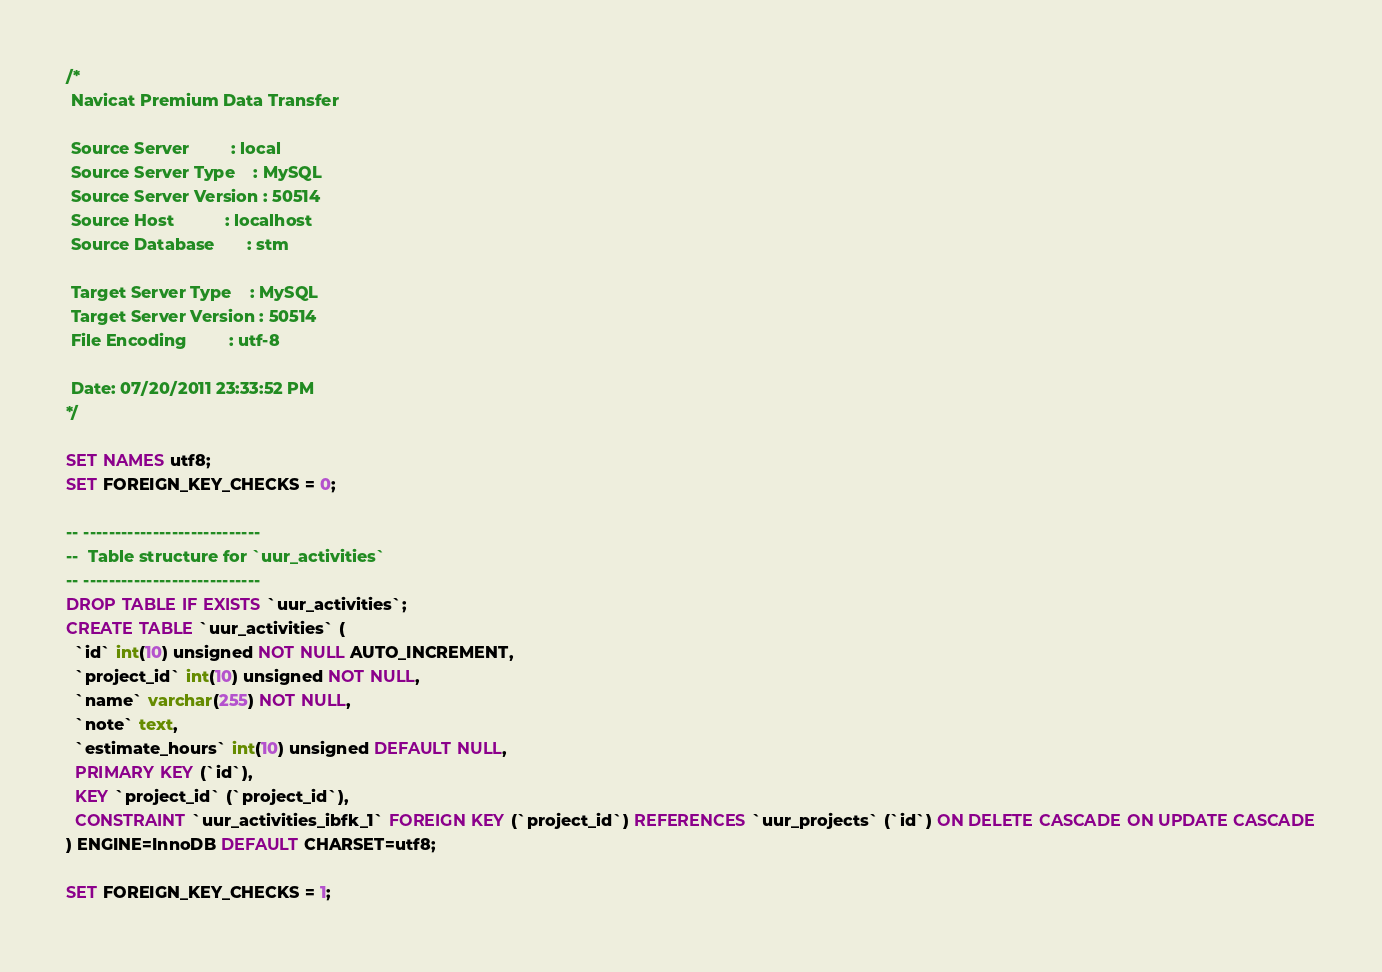<code> <loc_0><loc_0><loc_500><loc_500><_SQL_>/*
 Navicat Premium Data Transfer

 Source Server         : local
 Source Server Type    : MySQL
 Source Server Version : 50514
 Source Host           : localhost
 Source Database       : stm

 Target Server Type    : MySQL
 Target Server Version : 50514
 File Encoding         : utf-8

 Date: 07/20/2011 23:33:52 PM
*/

SET NAMES utf8;
SET FOREIGN_KEY_CHECKS = 0;

-- ----------------------------
--  Table structure for `uur_activities`
-- ----------------------------
DROP TABLE IF EXISTS `uur_activities`;
CREATE TABLE `uur_activities` (
  `id` int(10) unsigned NOT NULL AUTO_INCREMENT,
  `project_id` int(10) unsigned NOT NULL,
  `name` varchar(255) NOT NULL,
  `note` text,
  `estimate_hours` int(10) unsigned DEFAULT NULL,
  PRIMARY KEY (`id`),
  KEY `project_id` (`project_id`),
  CONSTRAINT `uur_activities_ibfk_1` FOREIGN KEY (`project_id`) REFERENCES `uur_projects` (`id`) ON DELETE CASCADE ON UPDATE CASCADE
) ENGINE=InnoDB DEFAULT CHARSET=utf8;

SET FOREIGN_KEY_CHECKS = 1;
</code> 